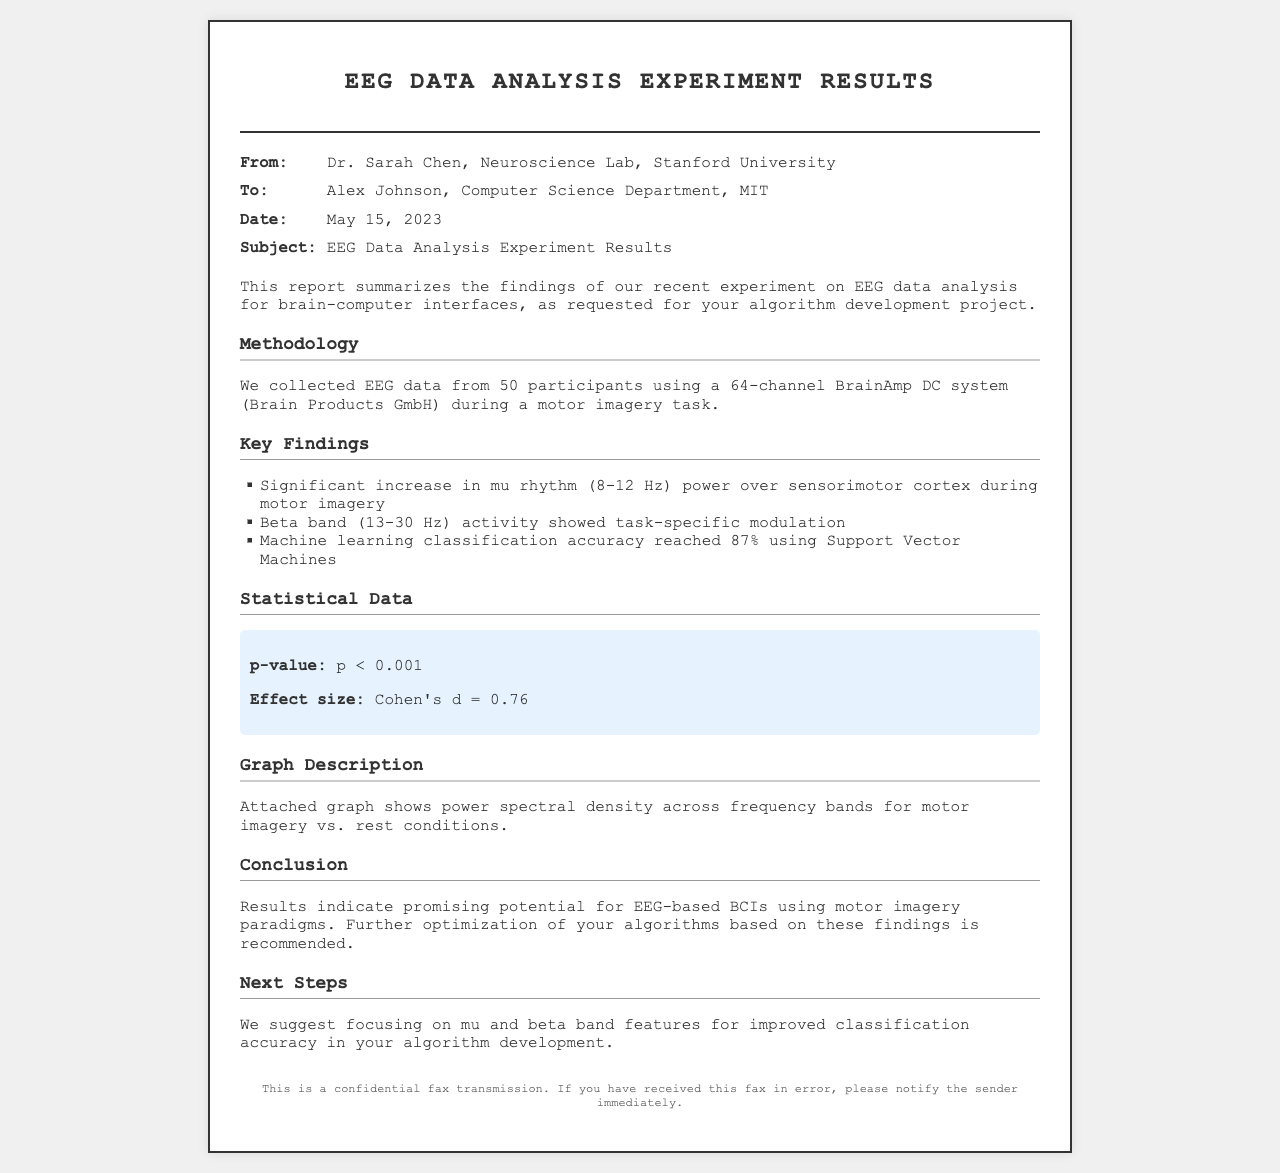What is the name of the sender? The sender of the fax is Dr. Sarah Chen, from the Neuroscience Lab at Stanford University.
Answer: Dr. Sarah Chen What is the date of the report? The date indicated in the fax for this EEG data analysis report is May 15, 2023.
Answer: May 15, 2023 What was the classification accuracy achieved using machine learning? The document states that a machine learning classification accuracy of 87% was achieved.
Answer: 87% What is the significant frequency band analyzed during motor imagery? The significant frequency band analyzed during motor imagery is the mu rhythm, which is between 8-12 Hz.
Answer: mu rhythm (8-12 Hz) What is the p-value reported in the statistical data? The reported p-value in the statistical data section is less than 0.001, indicating a significant result.
Answer: p < 0.001 Why is focusing on mu and beta band features recommended? The recommendation is based on their indicated potential for improved classification accuracy in the algorithm development.
Answer: Improved classification accuracy What does Cohen's d represent in this report? Cohen's d represents the effect size, which in this case is indicated to be 0.76, signaling a medium to large effect.
Answer: Cohen's d = 0.76 Which task were the participants engaged in during the EEG data collection? The participants were engaged in a motor imagery task while the EEG data was collected.
Answer: motor imagery task What type of system was used to collect the EEG data? The EEG data was collected using a 64-channel BrainAmp DC system provided by Brain Products GmbH.
Answer: 64-channel BrainAmp DC system 